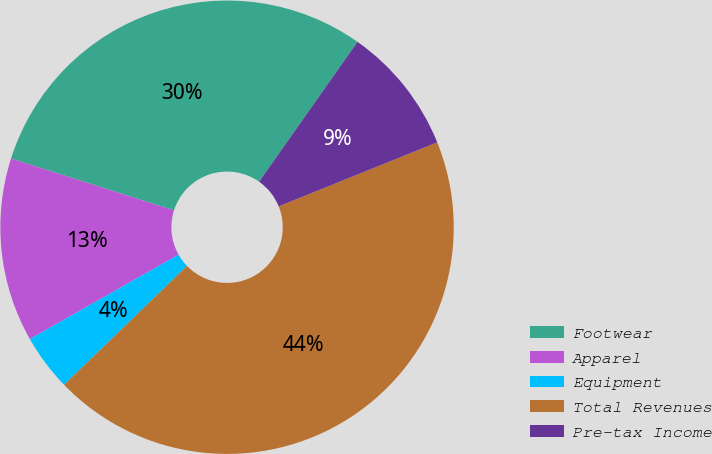Convert chart. <chart><loc_0><loc_0><loc_500><loc_500><pie_chart><fcel>Footwear<fcel>Apparel<fcel>Equipment<fcel>Total Revenues<fcel>Pre-tax Income<nl><fcel>29.86%<fcel>13.11%<fcel>4.02%<fcel>43.88%<fcel>9.13%<nl></chart> 